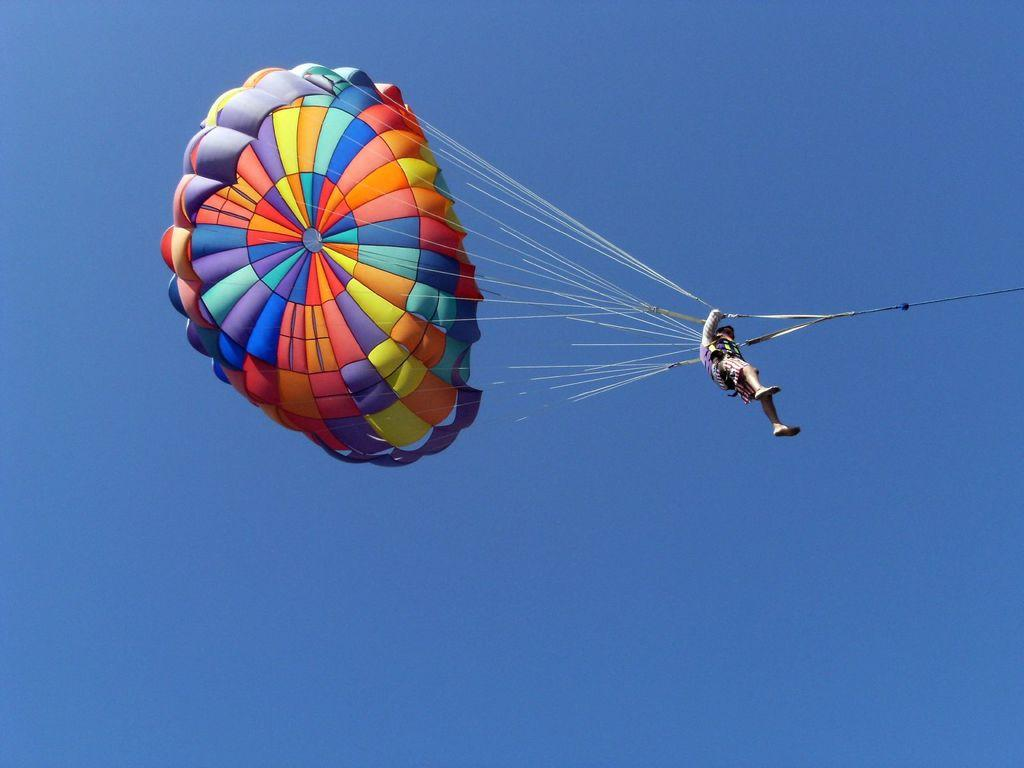What is the main object in the image? There is a parachute in the image. Is there anyone associated with the parachute? Yes, there is a person in the image. What is the color of the sky in the image? The sky is blue in the image. What type of advertisement can be seen on the boats in the image? There are no boats present in the image, so there is no advertisement on any boats. 